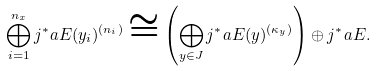<formula> <loc_0><loc_0><loc_500><loc_500>\bigoplus _ { i = 1 } ^ { n _ { x } } j ^ { * } _ { \ } a E ( y _ { i } ) ^ { ( n _ { i } ) } \cong \left ( \bigoplus _ { y \in J } j ^ { * } _ { \ } a E ( y ) ^ { ( \kappa _ { y } ) } \right ) \oplus j ^ { * } _ { \ } a E .</formula> 